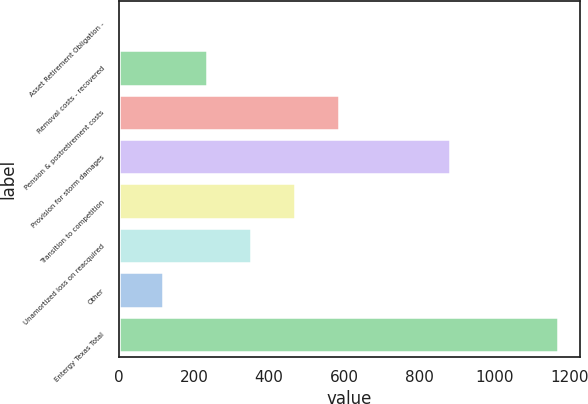Convert chart. <chart><loc_0><loc_0><loc_500><loc_500><bar_chart><fcel>Asset Retirement Obligation -<fcel>Removal costs - recovered<fcel>Pension & postretirement costs<fcel>Provision for storm damages<fcel>Transition to competition<fcel>Unamortized loss on reacquired<fcel>Other<fcel>Entergy Texas Total<nl><fcel>1.4<fcel>234.92<fcel>585.2<fcel>881.7<fcel>468.44<fcel>351.68<fcel>118.16<fcel>1169<nl></chart> 